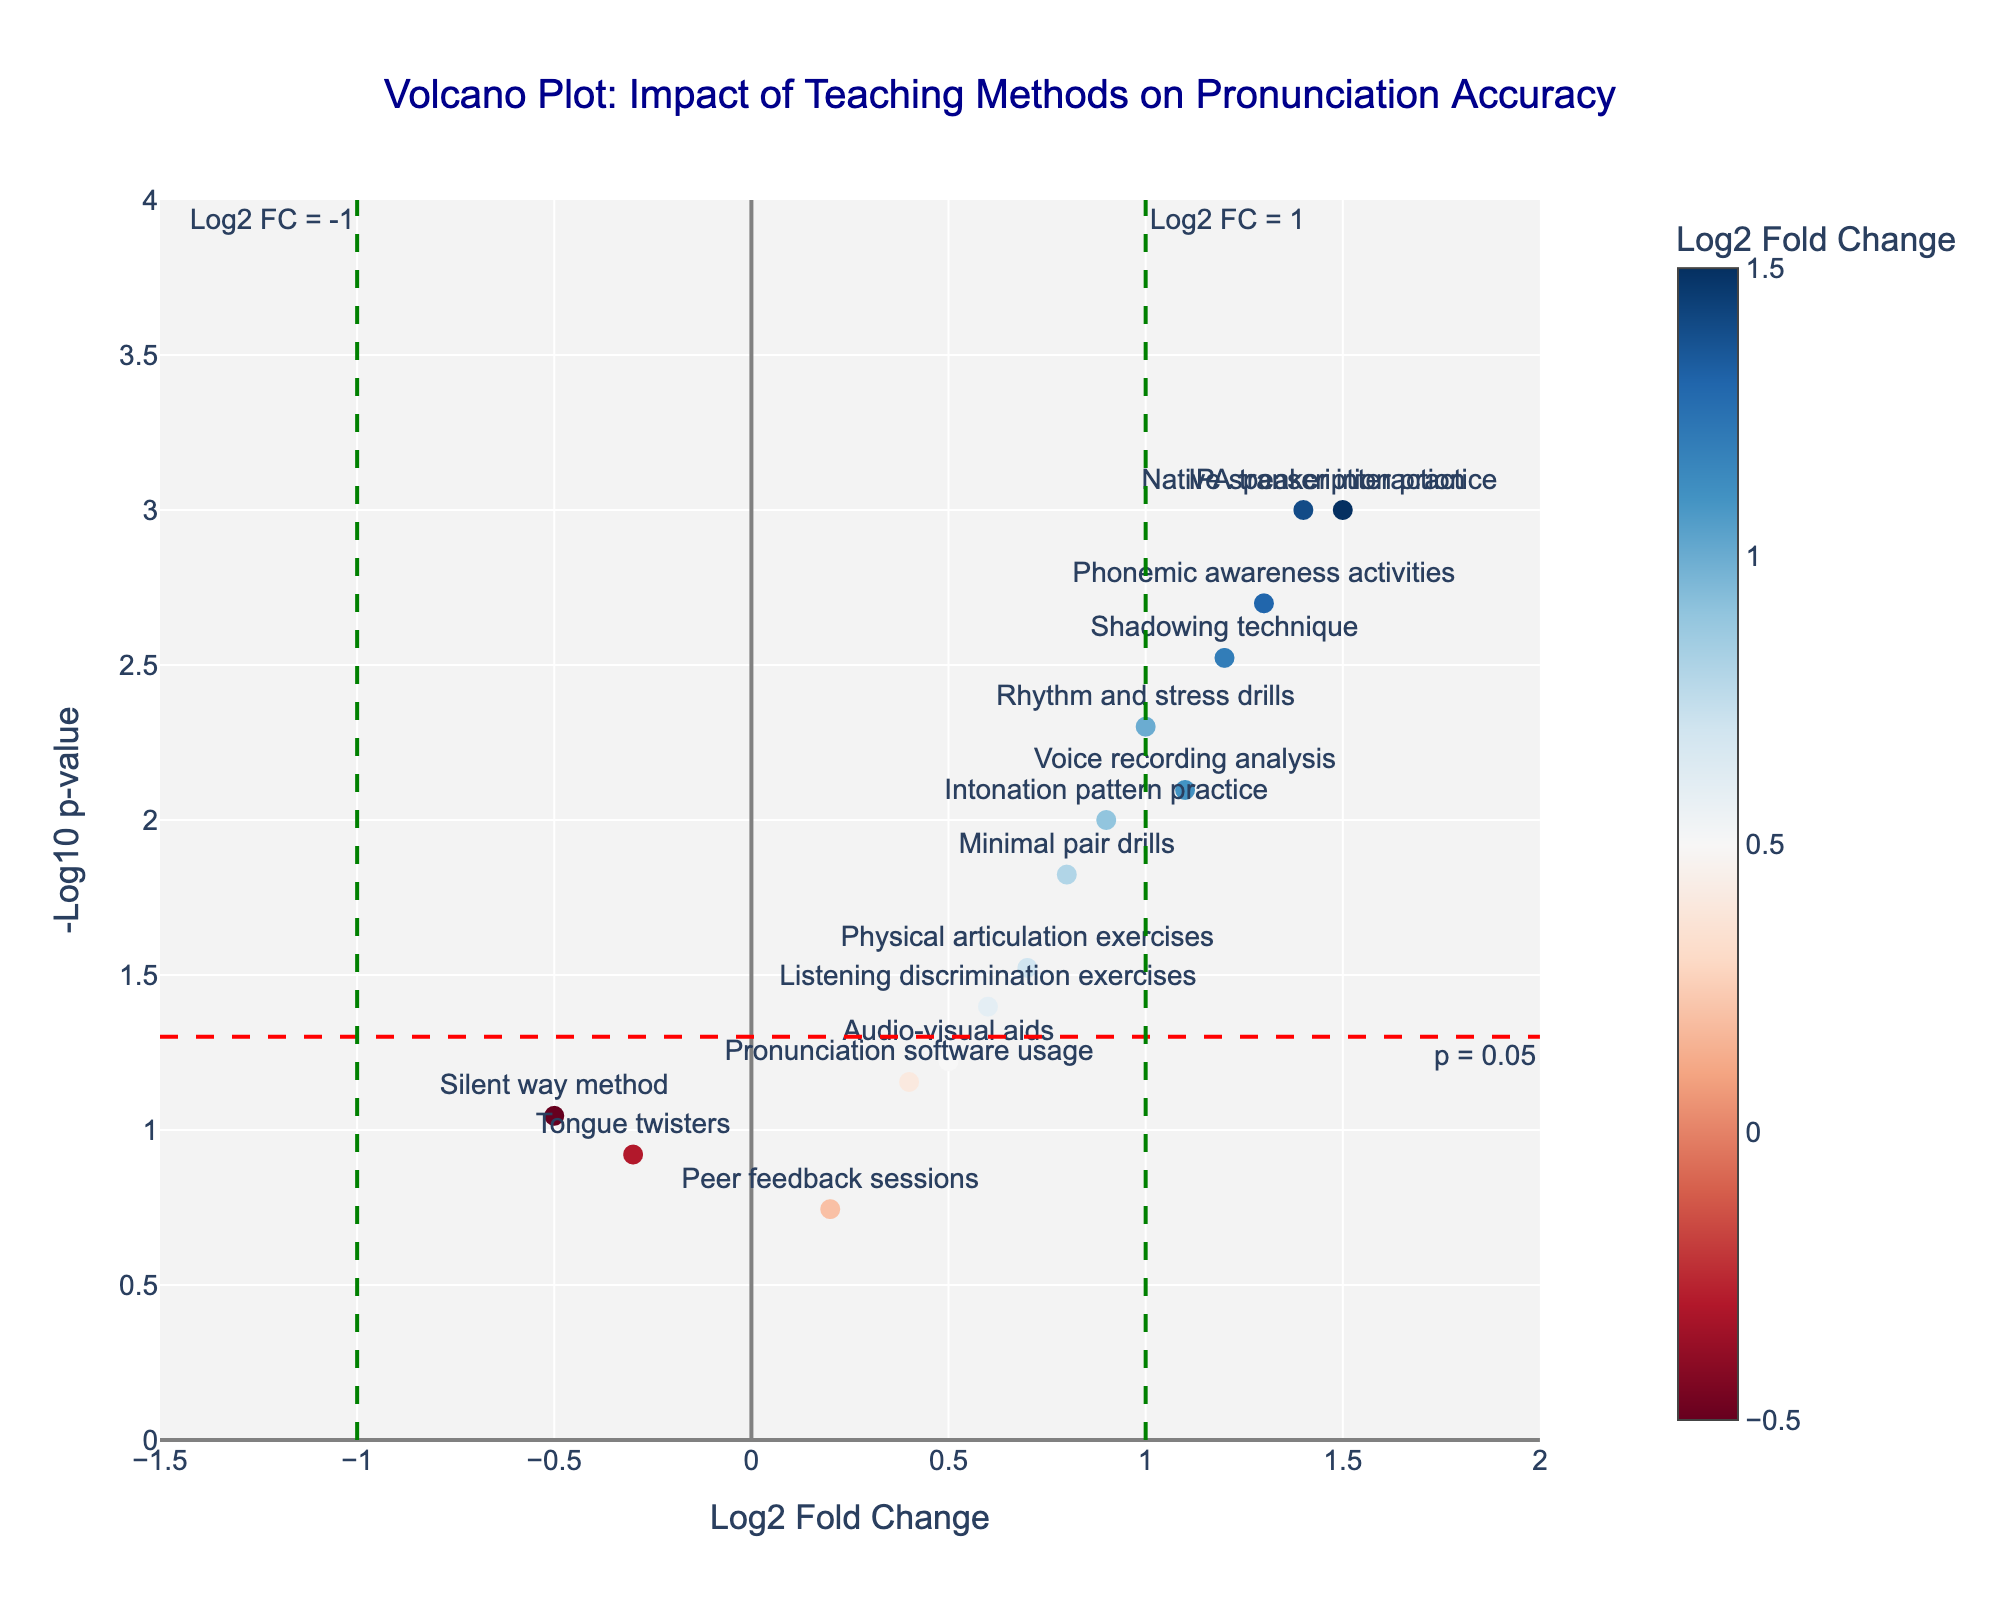What is the title of the figure? The title of the figure is located at the top and is usually the most prominent text. Here, it reads: "Volcano Plot: Impact of Teaching Methods on Pronunciation Accuracy".
Answer: Volcano Plot: Impact of Teaching Methods on Pronunciation Accuracy Which teaching method has the highest -log10 p-value? Look at the y-axis for the highest -log10 p-value and then check the corresponding teaching method labeled next to the point on the plot. The highest -log10 p-value is associated with "IPA transcription practice".
Answer: IPA transcription practice What does a point with a negative log2 fold change represent in this plot? Points with a negative log2 fold change are located on the left side of the vertical line (Log2 FC = 0) and indicate that the teaching method leads to a decrease in pronunciation accuracy.
Answer: Decrease in pronunciation accuracy How many teaching methods have a p-value lower than 0.05? Check the y-axis for the line corresponding to -log10(p-value) = 1.3 (since -log10(0.05) ≈ 1.3), and count the number of points with -log10(p-value) above this line. There are 10 points above this threshold.
Answer: 10 What do the color scales of the markers represent in the figure? The color scale represents the log2 fold change values of the teaching methods. Points with higher log2 fold change are indicated in a lighter color, and those with lower log2 fold change are in a darker color.
Answer: Log2 fold change values Which teaching method shows both a significant improvement and the largest impact on pronunciation accuracy? Identify the method with the highest log2 fold change that also has a p-value lower than 0.05 (points above the red dashed line). "IPA transcription practice" has the highest log2 fold change (1.5) with a p-value of 0.001.
Answer: IPA transcription practice How does the method "Silent way method" compare to others in terms of log2 fold change and p-value? Find the point for "Silent way method" on the plot, located left of the origin (negative log2 fold change of -0.5) and under the red dashed line (p-value > 0.05 or -log10(p) < 1.3). This method shows a non-significant decrease in pronunciation accuracy.
Answer: Non-significant decrease What conclusion can be drawn for teaching methods right of the green dashed line (Log2 FC = 1)? Teaching methods to the right of this line have a log2 fold change greater than 1, indicating a more substantial increase in pronunciation accuracy. Methods here include "Shadowing technique", "IPA transcription practice", "Native speaker interaction", and "Phonemic awareness activities".
Answer: Substantial increase in pronunciation accuracy Among the methods "Rhythm and stress drills" and "Voice recording analysis", which has a lower p-value? Locate both methods and compare their -log10(p-value) positions on the plot. "Rhythm and stress drills" (-log10(p)=2.3) is higher than "Voice recording analysis" (-log10(p)=2.1), meaning it has the lower p-value.
Answer: Rhythm and stress drills 